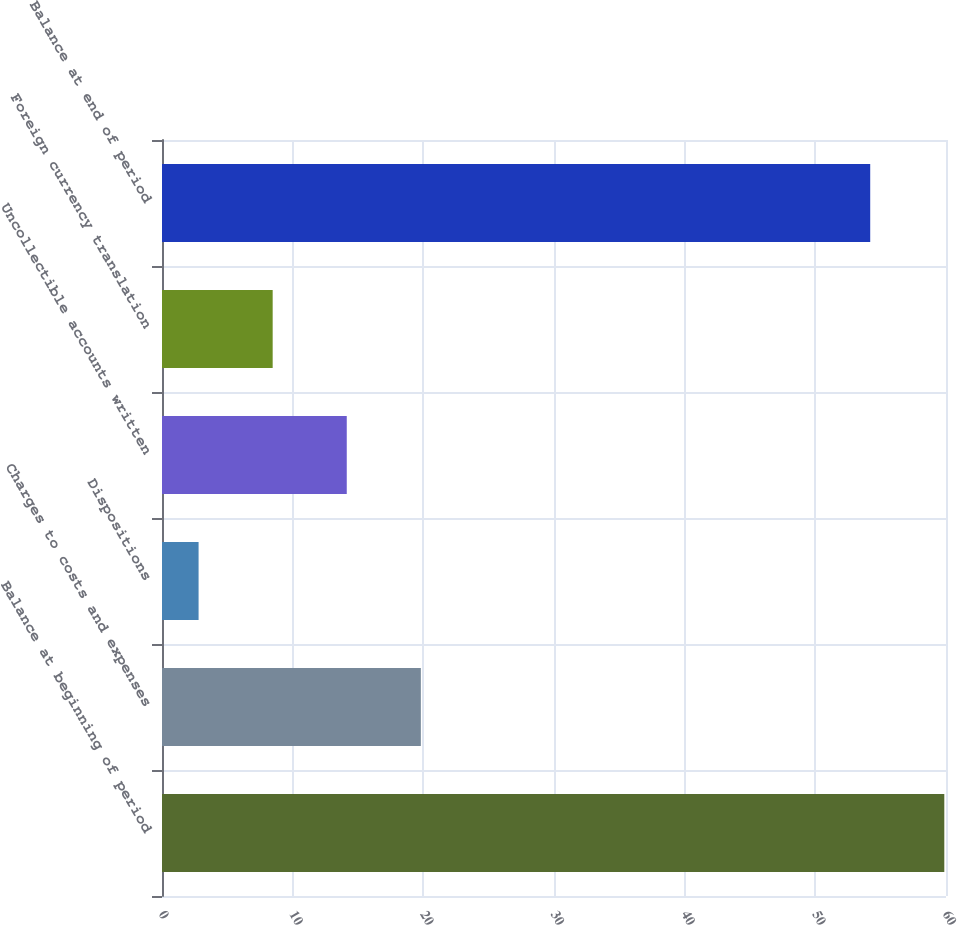<chart> <loc_0><loc_0><loc_500><loc_500><bar_chart><fcel>Balance at beginning of period<fcel>Charges to costs and expenses<fcel>Dispositions<fcel>Uncollectible accounts written<fcel>Foreign currency translation<fcel>Balance at end of period<nl><fcel>59.87<fcel>19.81<fcel>2.8<fcel>14.14<fcel>8.47<fcel>54.2<nl></chart> 